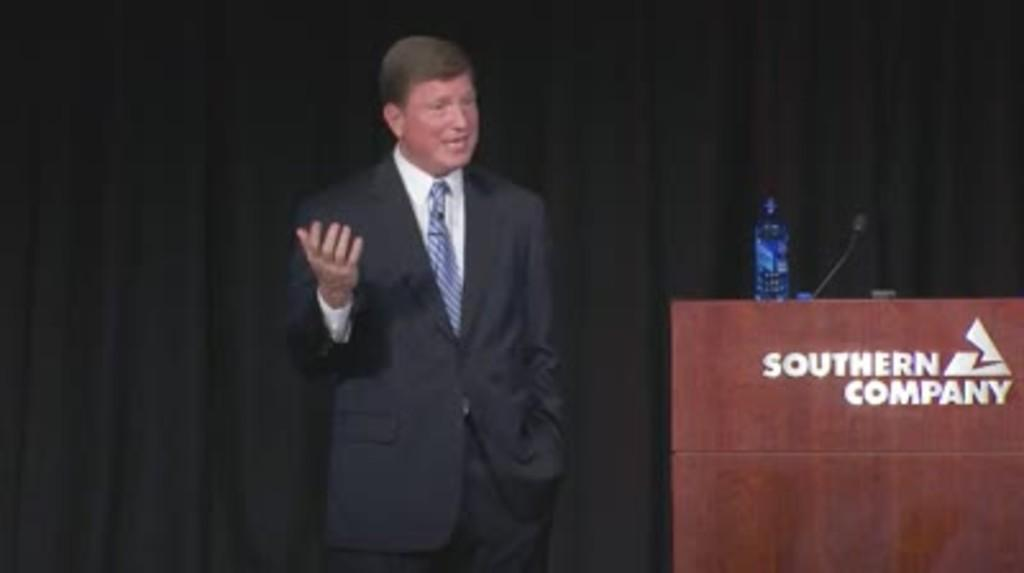What is the main subject of the image? There is a person in the image. What is the person wearing? The person is wearing a black suit. What is the person doing in the image? The person is standing. What can be seen beside the person? There is a wooden stand beside the person. What is on the wooden stand? The wooden stand has a mic and a water bottle on it. How many cows are visible in the image? There are no cows present in the image. What type of writing instrument is the person holding in the image? The person is not holding a quill or any writing instrument in the image. 